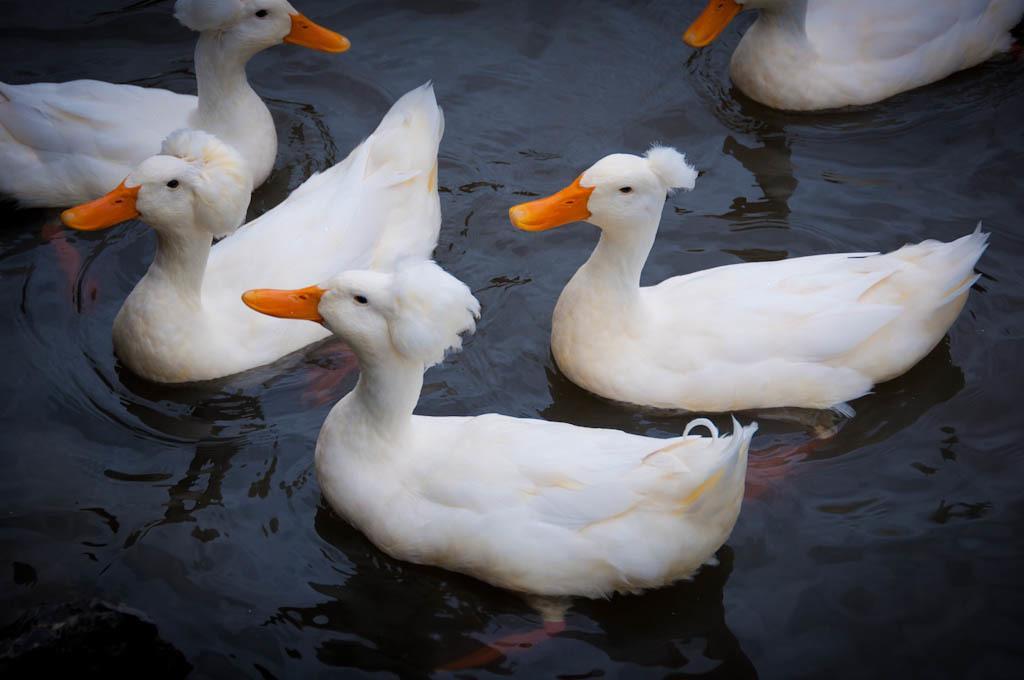Describe this image in one or two sentences. In this picture I see number of ducks, which are of white in color and I see that they're on the water. 